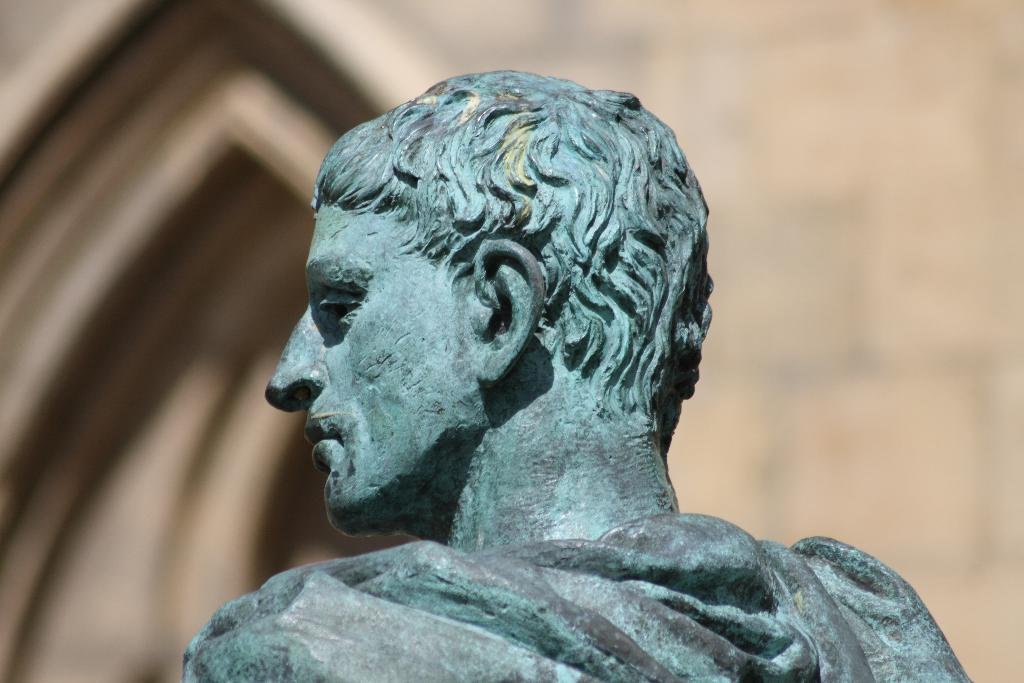What is the main subject of the image? There is a statue in the image. What type of comb can be seen in the image? There is no comb present in the image; it features a statue. What question is being asked by the statue in the image? There is no indication that the statue is asking a question in the image. 